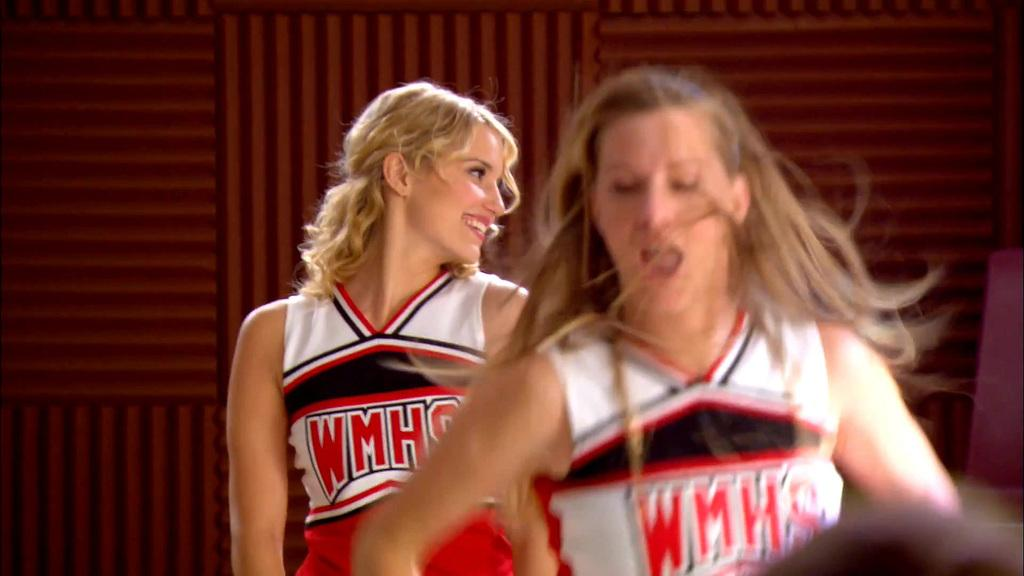<image>
Write a terse but informative summary of the picture. a couple of cheerleaders that are wearing WMHS 